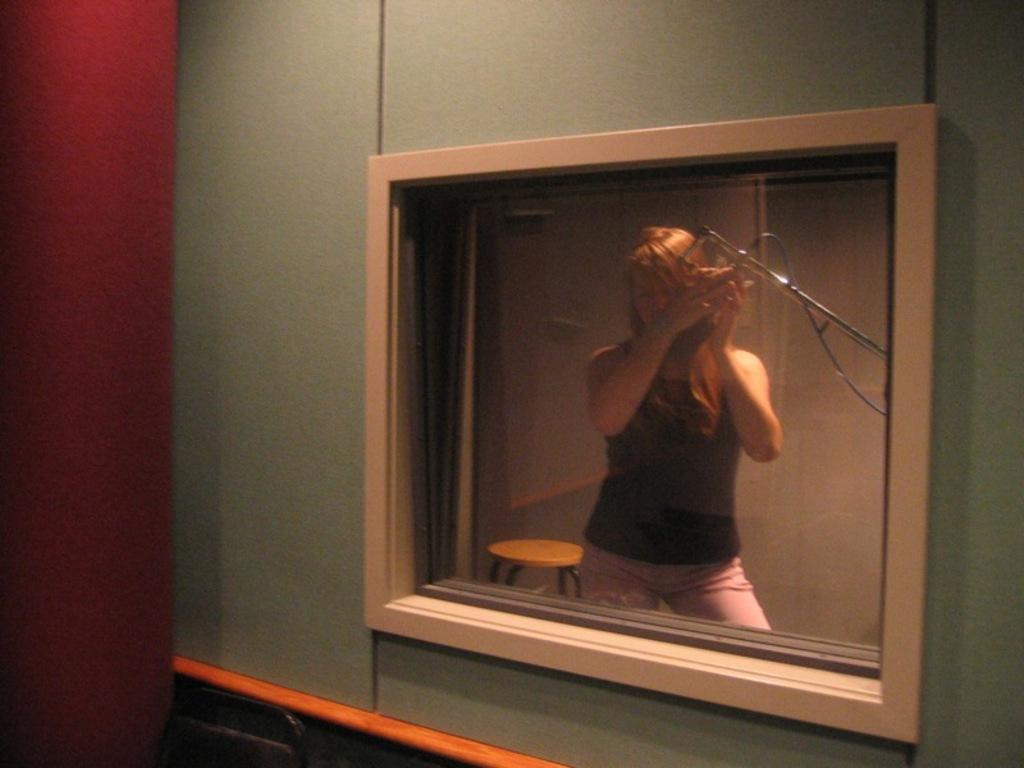What is the main subject of the image? There is a woman standing in the image. What is the woman holding in the image? The woman is holding an object. Can you describe the background of the image? There is a stool behind the woman. How many jellyfish can be seen swimming in the background of the image? There are no jellyfish present in the image. What type of society is depicted in the image? The image does not depict any society; it features a woman standing and holding an object. 